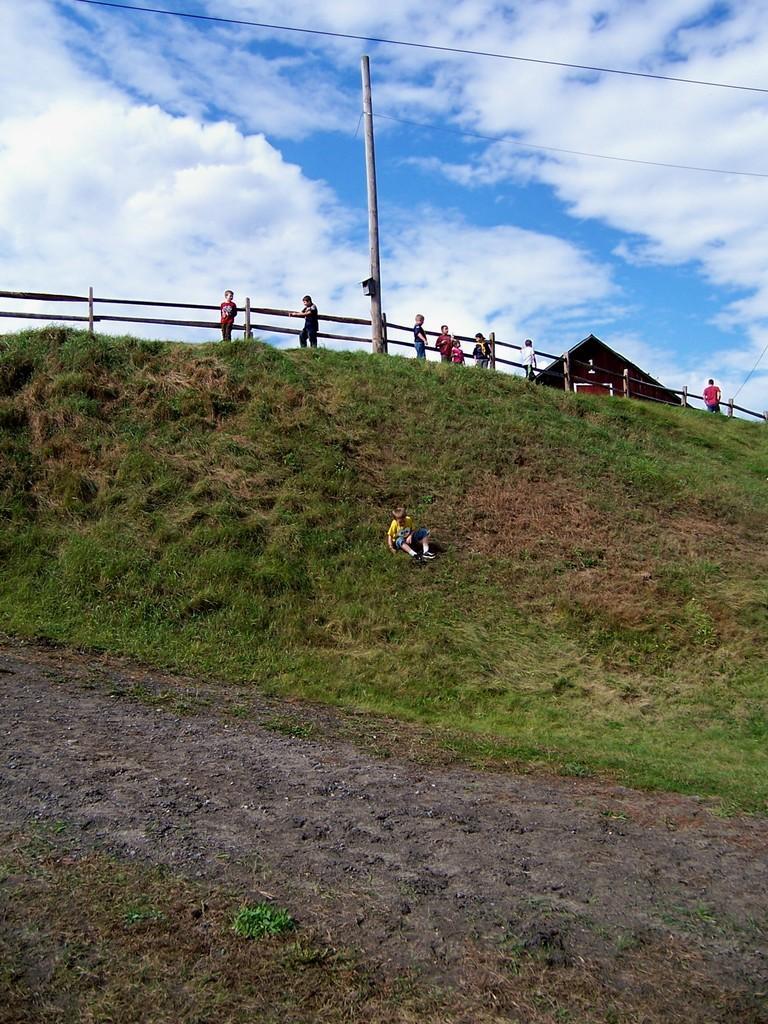Describe this image in one or two sentences. Here we can see grass, fence, pole, house and people. Background we can see cloudy sky. 